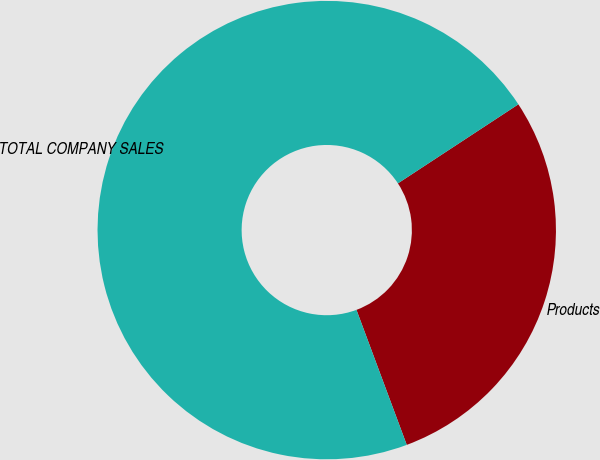<chart> <loc_0><loc_0><loc_500><loc_500><pie_chart><fcel>Products<fcel>TOTAL COMPANY SALES<nl><fcel>28.57%<fcel>71.43%<nl></chart> 